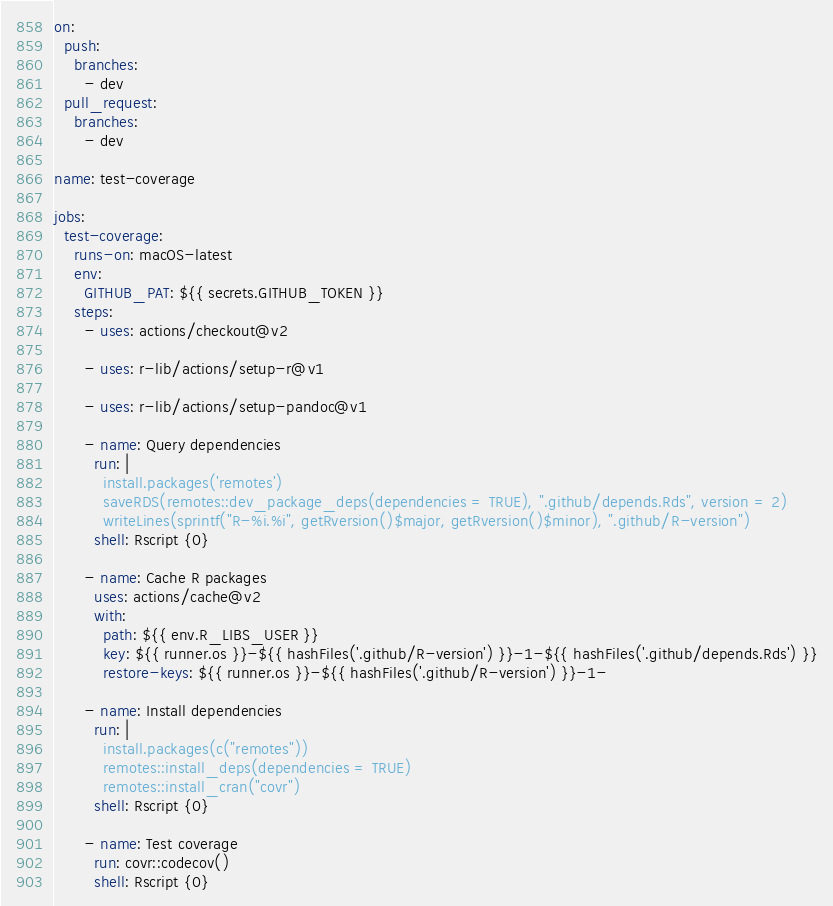<code> <loc_0><loc_0><loc_500><loc_500><_YAML_>on:
  push:
    branches:
      - dev
  pull_request:
    branches:
      - dev

name: test-coverage

jobs:
  test-coverage:
    runs-on: macOS-latest
    env:
      GITHUB_PAT: ${{ secrets.GITHUB_TOKEN }}
    steps:
      - uses: actions/checkout@v2

      - uses: r-lib/actions/setup-r@v1

      - uses: r-lib/actions/setup-pandoc@v1

      - name: Query dependencies
        run: |
          install.packages('remotes')
          saveRDS(remotes::dev_package_deps(dependencies = TRUE), ".github/depends.Rds", version = 2)
          writeLines(sprintf("R-%i.%i", getRversion()$major, getRversion()$minor), ".github/R-version")
        shell: Rscript {0}

      - name: Cache R packages
        uses: actions/cache@v2
        with:
          path: ${{ env.R_LIBS_USER }}
          key: ${{ runner.os }}-${{ hashFiles('.github/R-version') }}-1-${{ hashFiles('.github/depends.Rds') }}
          restore-keys: ${{ runner.os }}-${{ hashFiles('.github/R-version') }}-1-

      - name: Install dependencies
        run: |
          install.packages(c("remotes"))
          remotes::install_deps(dependencies = TRUE)
          remotes::install_cran("covr")
        shell: Rscript {0}

      - name: Test coverage
        run: covr::codecov()
        shell: Rscript {0}
</code> 